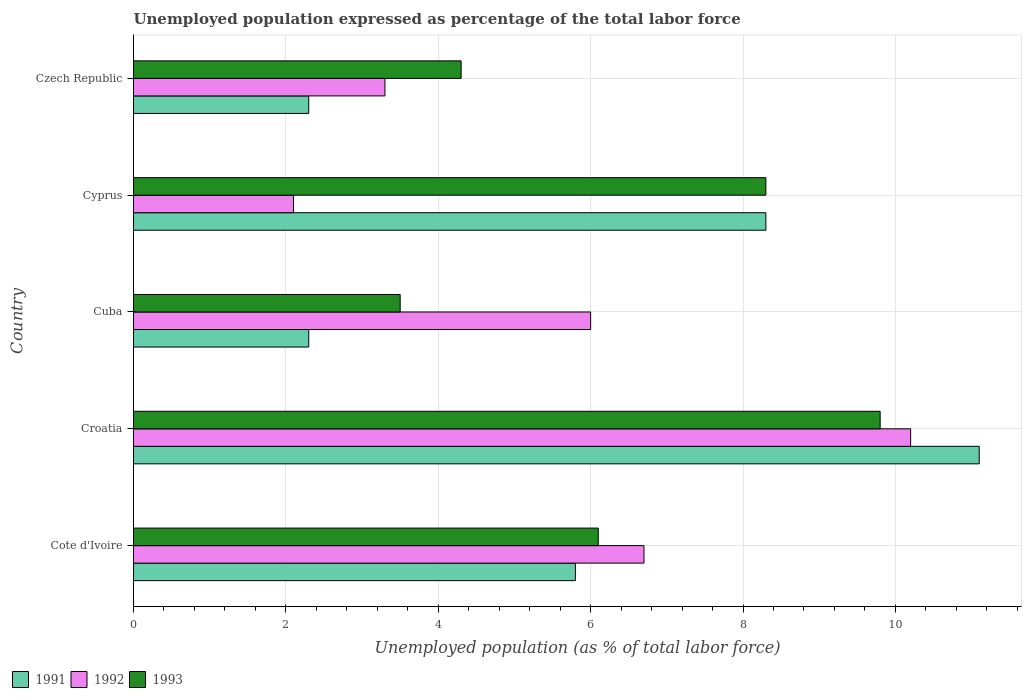How many different coloured bars are there?
Keep it short and to the point. 3. How many groups of bars are there?
Offer a very short reply. 5. Are the number of bars on each tick of the Y-axis equal?
Give a very brief answer. Yes. How many bars are there on the 3rd tick from the top?
Provide a short and direct response. 3. How many bars are there on the 4th tick from the bottom?
Your answer should be very brief. 3. What is the label of the 5th group of bars from the top?
Keep it short and to the point. Cote d'Ivoire. What is the unemployment in in 1993 in Cyprus?
Provide a succinct answer. 8.3. Across all countries, what is the maximum unemployment in in 1992?
Offer a very short reply. 10.2. Across all countries, what is the minimum unemployment in in 1993?
Provide a succinct answer. 3.5. In which country was the unemployment in in 1993 maximum?
Give a very brief answer. Croatia. In which country was the unemployment in in 1991 minimum?
Provide a succinct answer. Cuba. What is the total unemployment in in 1992 in the graph?
Provide a succinct answer. 28.3. What is the difference between the unemployment in in 1991 in Cuba and the unemployment in in 1992 in Czech Republic?
Ensure brevity in your answer.  -1. What is the average unemployment in in 1991 per country?
Keep it short and to the point. 5.96. What is the difference between the unemployment in in 1993 and unemployment in in 1991 in Cuba?
Ensure brevity in your answer.  1.2. What is the ratio of the unemployment in in 1991 in Cote d'Ivoire to that in Cuba?
Your response must be concise. 2.52. What is the difference between the highest and the second highest unemployment in in 1992?
Ensure brevity in your answer.  3.5. What is the difference between the highest and the lowest unemployment in in 1991?
Ensure brevity in your answer.  8.8. Is the sum of the unemployment in in 1993 in Cuba and Czech Republic greater than the maximum unemployment in in 1992 across all countries?
Ensure brevity in your answer.  No. What does the 3rd bar from the top in Cuba represents?
Keep it short and to the point. 1991. What does the 1st bar from the bottom in Cote d'Ivoire represents?
Your answer should be very brief. 1991. Is it the case that in every country, the sum of the unemployment in in 1991 and unemployment in in 1992 is greater than the unemployment in in 1993?
Offer a very short reply. Yes. Are all the bars in the graph horizontal?
Give a very brief answer. Yes. What is the difference between two consecutive major ticks on the X-axis?
Offer a terse response. 2. Where does the legend appear in the graph?
Your answer should be compact. Bottom left. What is the title of the graph?
Give a very brief answer. Unemployed population expressed as percentage of the total labor force. What is the label or title of the X-axis?
Give a very brief answer. Unemployed population (as % of total labor force). What is the label or title of the Y-axis?
Keep it short and to the point. Country. What is the Unemployed population (as % of total labor force) of 1991 in Cote d'Ivoire?
Offer a very short reply. 5.8. What is the Unemployed population (as % of total labor force) of 1992 in Cote d'Ivoire?
Ensure brevity in your answer.  6.7. What is the Unemployed population (as % of total labor force) of 1993 in Cote d'Ivoire?
Your answer should be compact. 6.1. What is the Unemployed population (as % of total labor force) of 1991 in Croatia?
Keep it short and to the point. 11.1. What is the Unemployed population (as % of total labor force) in 1992 in Croatia?
Keep it short and to the point. 10.2. What is the Unemployed population (as % of total labor force) in 1993 in Croatia?
Your answer should be very brief. 9.8. What is the Unemployed population (as % of total labor force) of 1991 in Cuba?
Make the answer very short. 2.3. What is the Unemployed population (as % of total labor force) in 1991 in Cyprus?
Provide a succinct answer. 8.3. What is the Unemployed population (as % of total labor force) of 1992 in Cyprus?
Your response must be concise. 2.1. What is the Unemployed population (as % of total labor force) in 1993 in Cyprus?
Ensure brevity in your answer.  8.3. What is the Unemployed population (as % of total labor force) in 1991 in Czech Republic?
Give a very brief answer. 2.3. What is the Unemployed population (as % of total labor force) in 1992 in Czech Republic?
Provide a short and direct response. 3.3. What is the Unemployed population (as % of total labor force) in 1993 in Czech Republic?
Keep it short and to the point. 4.3. Across all countries, what is the maximum Unemployed population (as % of total labor force) in 1991?
Provide a succinct answer. 11.1. Across all countries, what is the maximum Unemployed population (as % of total labor force) in 1992?
Ensure brevity in your answer.  10.2. Across all countries, what is the maximum Unemployed population (as % of total labor force) of 1993?
Offer a terse response. 9.8. Across all countries, what is the minimum Unemployed population (as % of total labor force) of 1991?
Keep it short and to the point. 2.3. Across all countries, what is the minimum Unemployed population (as % of total labor force) in 1992?
Offer a terse response. 2.1. What is the total Unemployed population (as % of total labor force) of 1991 in the graph?
Your response must be concise. 29.8. What is the total Unemployed population (as % of total labor force) of 1992 in the graph?
Provide a succinct answer. 28.3. What is the difference between the Unemployed population (as % of total labor force) in 1992 in Cote d'Ivoire and that in Croatia?
Offer a very short reply. -3.5. What is the difference between the Unemployed population (as % of total labor force) of 1991 in Cote d'Ivoire and that in Cuba?
Your response must be concise. 3.5. What is the difference between the Unemployed population (as % of total labor force) of 1992 in Cote d'Ivoire and that in Cuba?
Keep it short and to the point. 0.7. What is the difference between the Unemployed population (as % of total labor force) in 1993 in Cote d'Ivoire and that in Cyprus?
Ensure brevity in your answer.  -2.2. What is the difference between the Unemployed population (as % of total labor force) in 1991 in Cote d'Ivoire and that in Czech Republic?
Provide a succinct answer. 3.5. What is the difference between the Unemployed population (as % of total labor force) of 1991 in Croatia and that in Cuba?
Your answer should be compact. 8.8. What is the difference between the Unemployed population (as % of total labor force) of 1992 in Croatia and that in Cuba?
Provide a succinct answer. 4.2. What is the difference between the Unemployed population (as % of total labor force) in 1993 in Croatia and that in Czech Republic?
Provide a short and direct response. 5.5. What is the difference between the Unemployed population (as % of total labor force) of 1992 in Cuba and that in Cyprus?
Your answer should be compact. 3.9. What is the difference between the Unemployed population (as % of total labor force) of 1993 in Cuba and that in Cyprus?
Keep it short and to the point. -4.8. What is the difference between the Unemployed population (as % of total labor force) of 1993 in Cuba and that in Czech Republic?
Offer a very short reply. -0.8. What is the difference between the Unemployed population (as % of total labor force) in 1991 in Cyprus and that in Czech Republic?
Give a very brief answer. 6. What is the difference between the Unemployed population (as % of total labor force) in 1992 in Cyprus and that in Czech Republic?
Provide a short and direct response. -1.2. What is the difference between the Unemployed population (as % of total labor force) in 1992 in Cote d'Ivoire and the Unemployed population (as % of total labor force) in 1993 in Cuba?
Offer a terse response. 3.2. What is the difference between the Unemployed population (as % of total labor force) in 1991 in Cote d'Ivoire and the Unemployed population (as % of total labor force) in 1992 in Cyprus?
Offer a terse response. 3.7. What is the difference between the Unemployed population (as % of total labor force) in 1991 in Cote d'Ivoire and the Unemployed population (as % of total labor force) in 1993 in Cyprus?
Provide a short and direct response. -2.5. What is the difference between the Unemployed population (as % of total labor force) of 1992 in Cote d'Ivoire and the Unemployed population (as % of total labor force) of 1993 in Cyprus?
Give a very brief answer. -1.6. What is the difference between the Unemployed population (as % of total labor force) in 1991 in Croatia and the Unemployed population (as % of total labor force) in 1993 in Cuba?
Give a very brief answer. 7.6. What is the difference between the Unemployed population (as % of total labor force) in 1992 in Croatia and the Unemployed population (as % of total labor force) in 1993 in Cuba?
Give a very brief answer. 6.7. What is the difference between the Unemployed population (as % of total labor force) in 1992 in Croatia and the Unemployed population (as % of total labor force) in 1993 in Czech Republic?
Provide a short and direct response. 5.9. What is the difference between the Unemployed population (as % of total labor force) of 1992 in Cuba and the Unemployed population (as % of total labor force) of 1993 in Cyprus?
Your response must be concise. -2.3. What is the difference between the Unemployed population (as % of total labor force) of 1991 in Cuba and the Unemployed population (as % of total labor force) of 1993 in Czech Republic?
Provide a succinct answer. -2. What is the difference between the Unemployed population (as % of total labor force) of 1992 in Cuba and the Unemployed population (as % of total labor force) of 1993 in Czech Republic?
Provide a succinct answer. 1.7. What is the difference between the Unemployed population (as % of total labor force) in 1991 in Cyprus and the Unemployed population (as % of total labor force) in 1993 in Czech Republic?
Your answer should be compact. 4. What is the difference between the Unemployed population (as % of total labor force) in 1992 in Cyprus and the Unemployed population (as % of total labor force) in 1993 in Czech Republic?
Keep it short and to the point. -2.2. What is the average Unemployed population (as % of total labor force) of 1991 per country?
Provide a succinct answer. 5.96. What is the average Unemployed population (as % of total labor force) in 1992 per country?
Offer a terse response. 5.66. What is the difference between the Unemployed population (as % of total labor force) in 1992 and Unemployed population (as % of total labor force) in 1993 in Cote d'Ivoire?
Your answer should be very brief. 0.6. What is the difference between the Unemployed population (as % of total labor force) in 1991 and Unemployed population (as % of total labor force) in 1992 in Croatia?
Your response must be concise. 0.9. What is the difference between the Unemployed population (as % of total labor force) of 1992 and Unemployed population (as % of total labor force) of 1993 in Croatia?
Your answer should be very brief. 0.4. What is the difference between the Unemployed population (as % of total labor force) in 1991 and Unemployed population (as % of total labor force) in 1993 in Cuba?
Offer a terse response. -1.2. What is the difference between the Unemployed population (as % of total labor force) of 1992 and Unemployed population (as % of total labor force) of 1993 in Cuba?
Your answer should be compact. 2.5. What is the difference between the Unemployed population (as % of total labor force) in 1992 and Unemployed population (as % of total labor force) in 1993 in Cyprus?
Keep it short and to the point. -6.2. What is the difference between the Unemployed population (as % of total labor force) of 1992 and Unemployed population (as % of total labor force) of 1993 in Czech Republic?
Provide a succinct answer. -1. What is the ratio of the Unemployed population (as % of total labor force) in 1991 in Cote d'Ivoire to that in Croatia?
Provide a short and direct response. 0.52. What is the ratio of the Unemployed population (as % of total labor force) of 1992 in Cote d'Ivoire to that in Croatia?
Provide a succinct answer. 0.66. What is the ratio of the Unemployed population (as % of total labor force) of 1993 in Cote d'Ivoire to that in Croatia?
Offer a terse response. 0.62. What is the ratio of the Unemployed population (as % of total labor force) of 1991 in Cote d'Ivoire to that in Cuba?
Offer a terse response. 2.52. What is the ratio of the Unemployed population (as % of total labor force) in 1992 in Cote d'Ivoire to that in Cuba?
Make the answer very short. 1.12. What is the ratio of the Unemployed population (as % of total labor force) of 1993 in Cote d'Ivoire to that in Cuba?
Your response must be concise. 1.74. What is the ratio of the Unemployed population (as % of total labor force) in 1991 in Cote d'Ivoire to that in Cyprus?
Your response must be concise. 0.7. What is the ratio of the Unemployed population (as % of total labor force) in 1992 in Cote d'Ivoire to that in Cyprus?
Make the answer very short. 3.19. What is the ratio of the Unemployed population (as % of total labor force) in 1993 in Cote d'Ivoire to that in Cyprus?
Provide a succinct answer. 0.73. What is the ratio of the Unemployed population (as % of total labor force) in 1991 in Cote d'Ivoire to that in Czech Republic?
Offer a terse response. 2.52. What is the ratio of the Unemployed population (as % of total labor force) of 1992 in Cote d'Ivoire to that in Czech Republic?
Your answer should be very brief. 2.03. What is the ratio of the Unemployed population (as % of total labor force) in 1993 in Cote d'Ivoire to that in Czech Republic?
Make the answer very short. 1.42. What is the ratio of the Unemployed population (as % of total labor force) of 1991 in Croatia to that in Cuba?
Give a very brief answer. 4.83. What is the ratio of the Unemployed population (as % of total labor force) of 1991 in Croatia to that in Cyprus?
Your answer should be compact. 1.34. What is the ratio of the Unemployed population (as % of total labor force) in 1992 in Croatia to that in Cyprus?
Give a very brief answer. 4.86. What is the ratio of the Unemployed population (as % of total labor force) in 1993 in Croatia to that in Cyprus?
Your answer should be compact. 1.18. What is the ratio of the Unemployed population (as % of total labor force) of 1991 in Croatia to that in Czech Republic?
Your answer should be compact. 4.83. What is the ratio of the Unemployed population (as % of total labor force) of 1992 in Croatia to that in Czech Republic?
Your response must be concise. 3.09. What is the ratio of the Unemployed population (as % of total labor force) of 1993 in Croatia to that in Czech Republic?
Give a very brief answer. 2.28. What is the ratio of the Unemployed population (as % of total labor force) of 1991 in Cuba to that in Cyprus?
Your response must be concise. 0.28. What is the ratio of the Unemployed population (as % of total labor force) in 1992 in Cuba to that in Cyprus?
Provide a succinct answer. 2.86. What is the ratio of the Unemployed population (as % of total labor force) of 1993 in Cuba to that in Cyprus?
Keep it short and to the point. 0.42. What is the ratio of the Unemployed population (as % of total labor force) of 1991 in Cuba to that in Czech Republic?
Offer a terse response. 1. What is the ratio of the Unemployed population (as % of total labor force) in 1992 in Cuba to that in Czech Republic?
Ensure brevity in your answer.  1.82. What is the ratio of the Unemployed population (as % of total labor force) in 1993 in Cuba to that in Czech Republic?
Make the answer very short. 0.81. What is the ratio of the Unemployed population (as % of total labor force) in 1991 in Cyprus to that in Czech Republic?
Offer a very short reply. 3.61. What is the ratio of the Unemployed population (as % of total labor force) of 1992 in Cyprus to that in Czech Republic?
Provide a short and direct response. 0.64. What is the ratio of the Unemployed population (as % of total labor force) in 1993 in Cyprus to that in Czech Republic?
Provide a short and direct response. 1.93. What is the difference between the highest and the second highest Unemployed population (as % of total labor force) in 1991?
Offer a very short reply. 2.8. 